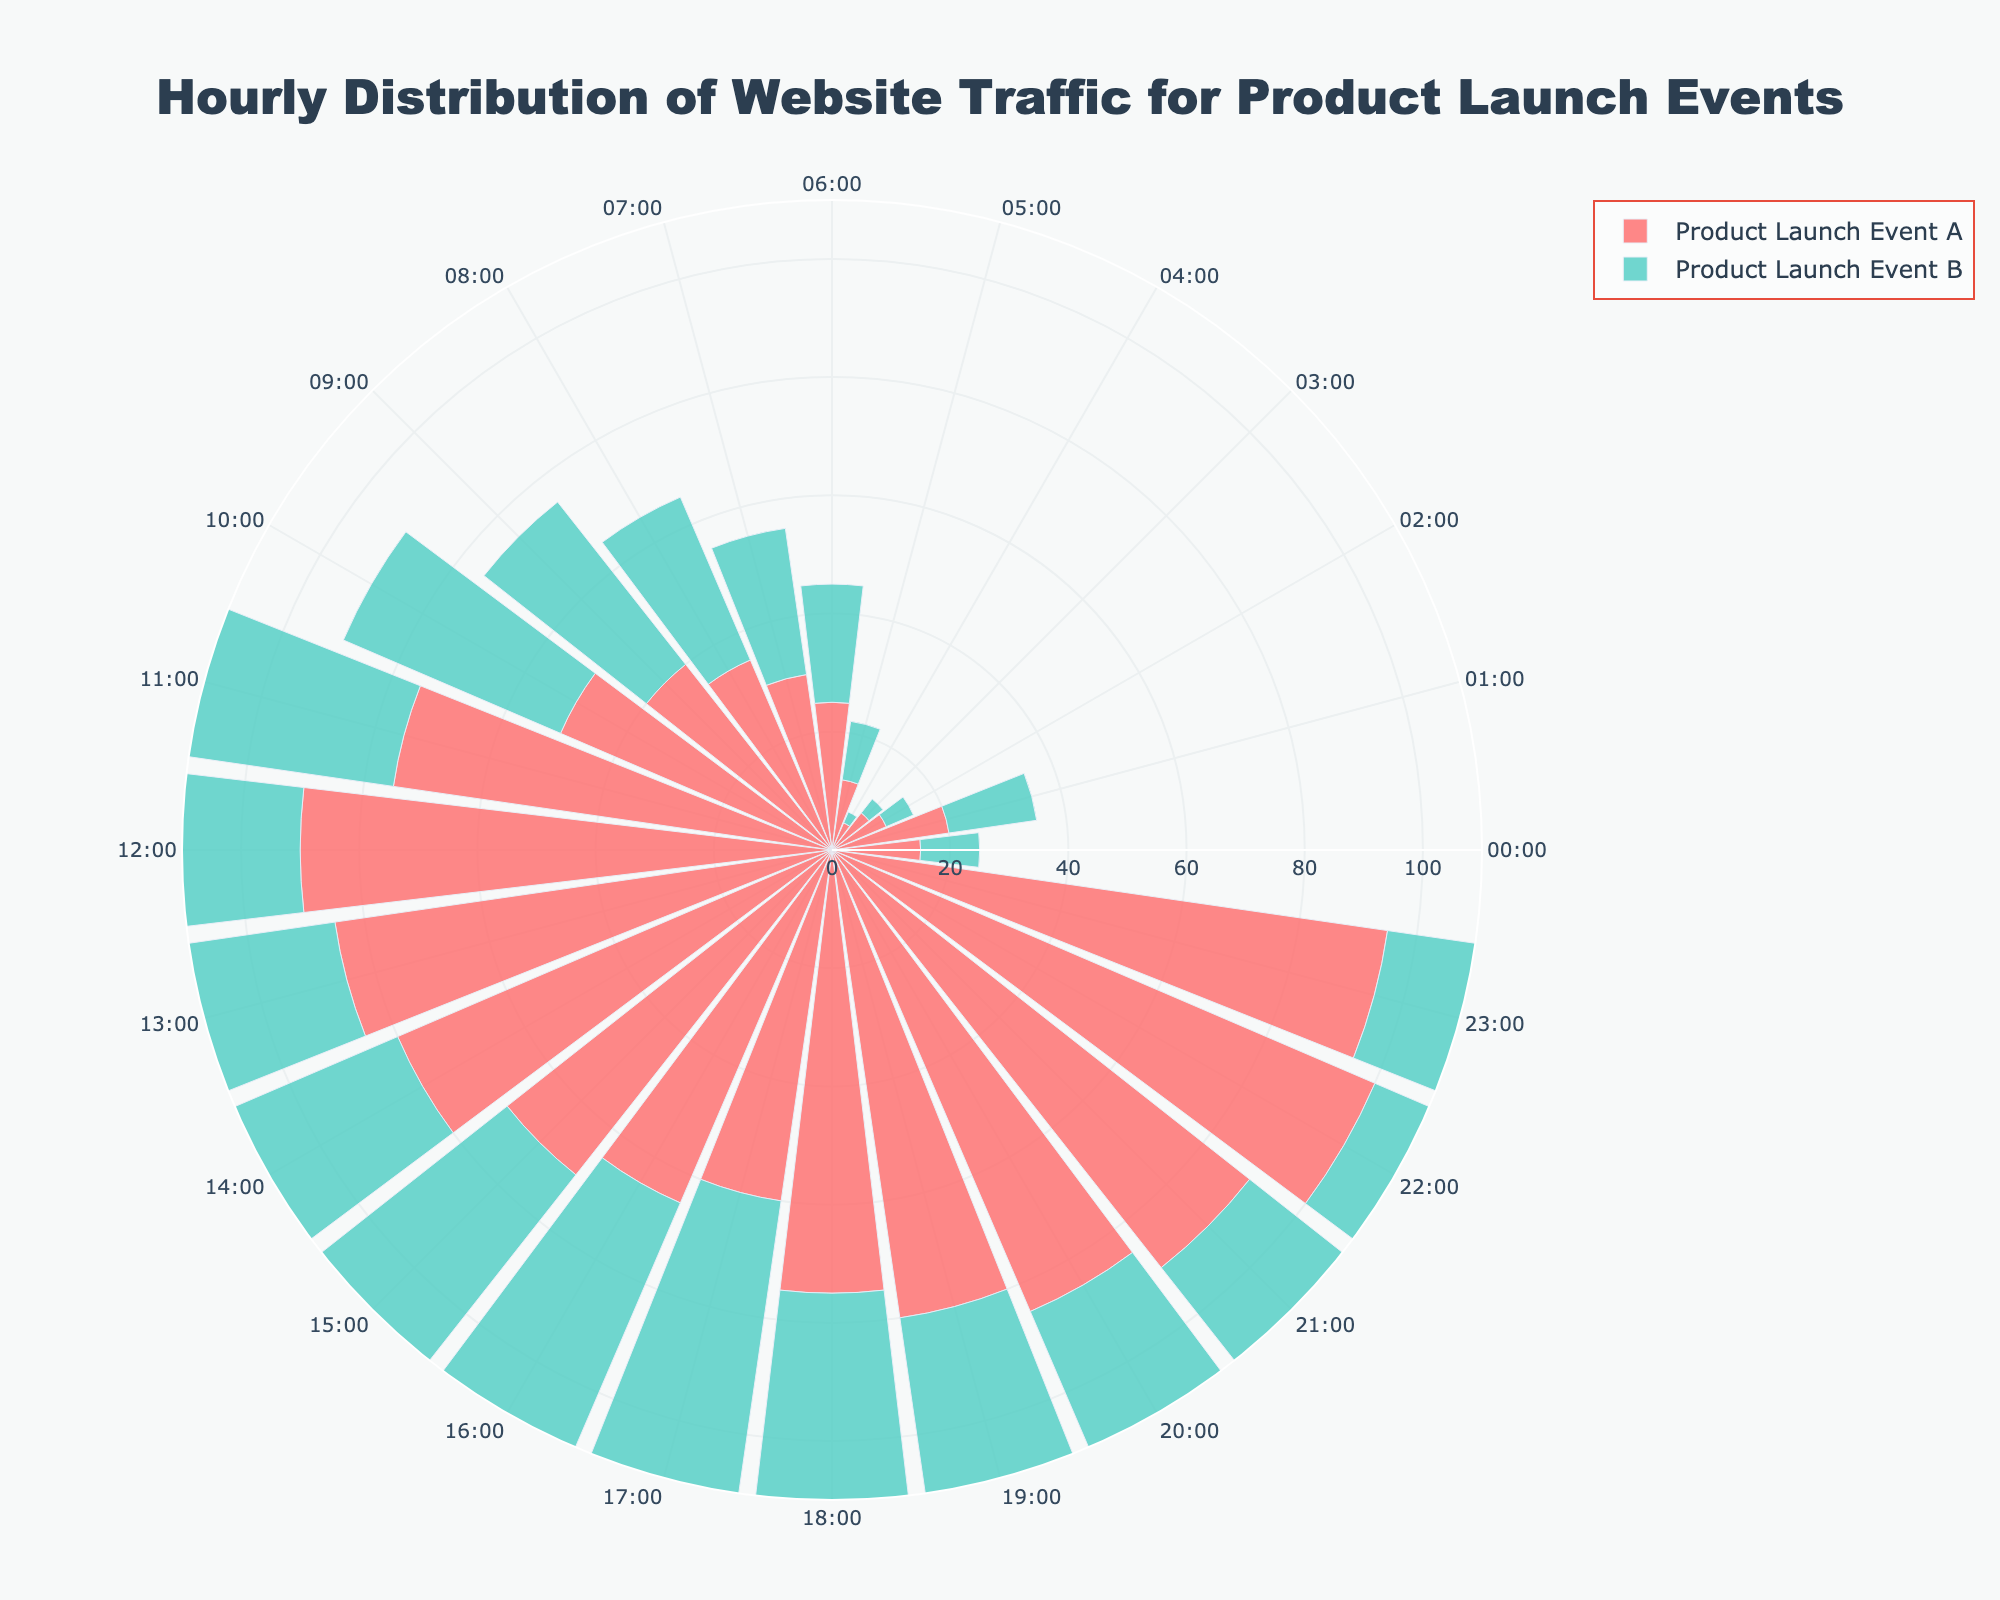What is the title of the chart? The chart's title is displayed at the top of the figure in a larger font size. It reads "Hourly Distribution of Website Traffic for Product Launch Events."
Answer: Hourly Distribution of Website Traffic for Product Launch Events What is the color used for Product Launch Event A? The data for Product Launch Event A is represented with a specific color. In the chart, the bars for this event are shaded in a light red or pink color.
Answer: Light red/pink At what time does Product Launch Event B have the maximum visits? Observing the radial lengths of the bars for Product Launch Event B, the longest bar corresponds to 20:00 (8 PM). This indicates the highest number of visits mainly occurred at this time.
Answer: 20:00 Which event has a higher peak at 12:00 noon? Comparing the bars for both events at 12:00, Product Launch Event A has more visits (90) than Product Launch Event B (60). Therefore, Event A has a higher peak at this hour.
Answer: Product Launch Event A How many visits were recorded at 03:00 for both events combined? To find the combined visits at 03:00, add the visits for both events: 8 (Event A) + 3 (Event B) = 11. Thus, the total visits for both events at this time is 11.
Answer: 11 Between which hours does Product Launch Event A have a consistent increase in visits? Analyzing the bar lengths for consecutive hours, Event A shows a consistent increase from 05:00 (12 visits) to 11:00 (75 visits).
Answer: 05:00 to 11:00 What is the average number of visits for Product Launch Event B between 18:00 and 21:00? The visits for Event B at 18:00, 19:00, 20:00, and 21:00 are 90, 95, 100, and 75, respectively. The average is (90 + 95 + 100 + 75) / 4 = 90.
Answer: 90 Which event has more stable traffic throughout the day? By observing the consistency of bars, Product Launch Event B has more uniform bar lengths, reflecting more stable traffic compared to Event A, which shows more fluctuation.
Answer: Product Launch Event B 